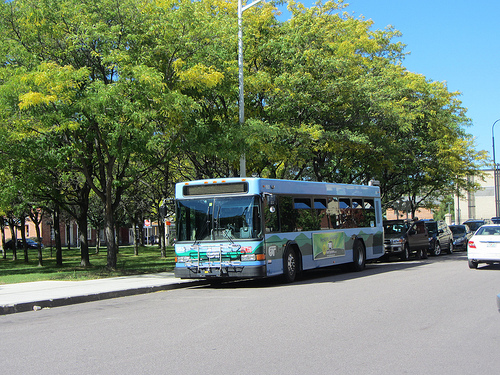What vehicle is in front of the green tree? The vehicle in front of the green tree is a bus. 